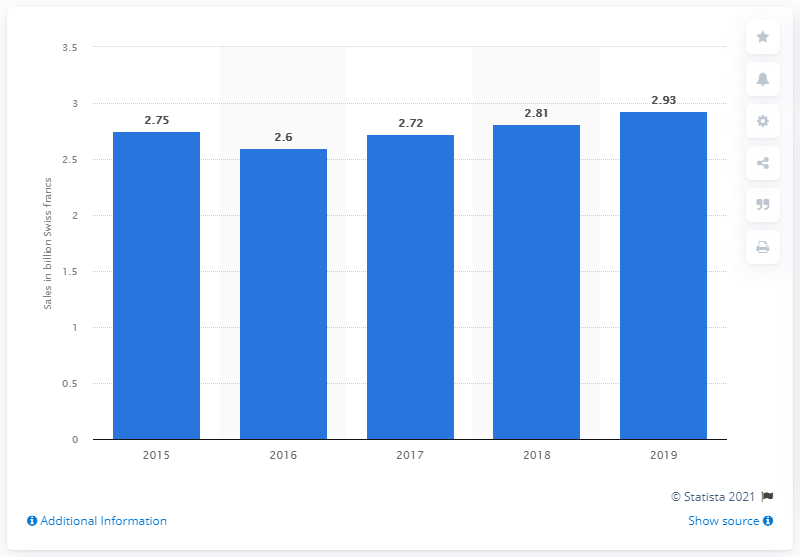Give some essential details in this illustration. In 2018, Nestlé was recognized as one of the leading food and beverage companies in Mexico. Nestlé's revenue from the previous year was 2.81 billion. In 2019, Nestlé generated revenue of 2.93 billion Mexican pesos in Mexico. 